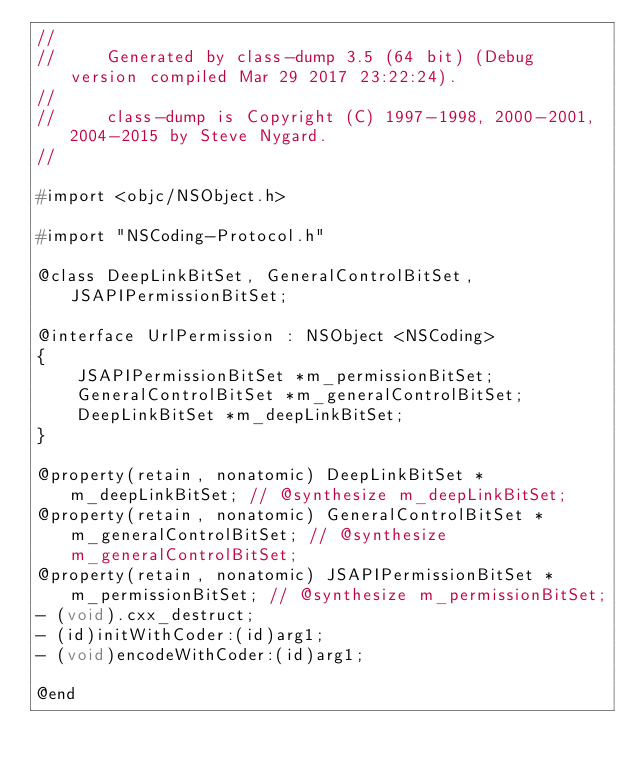Convert code to text. <code><loc_0><loc_0><loc_500><loc_500><_C_>//
//     Generated by class-dump 3.5 (64 bit) (Debug version compiled Mar 29 2017 23:22:24).
//
//     class-dump is Copyright (C) 1997-1998, 2000-2001, 2004-2015 by Steve Nygard.
//

#import <objc/NSObject.h>

#import "NSCoding-Protocol.h"

@class DeepLinkBitSet, GeneralControlBitSet, JSAPIPermissionBitSet;

@interface UrlPermission : NSObject <NSCoding>
{
    JSAPIPermissionBitSet *m_permissionBitSet;
    GeneralControlBitSet *m_generalControlBitSet;
    DeepLinkBitSet *m_deepLinkBitSet;
}

@property(retain, nonatomic) DeepLinkBitSet *m_deepLinkBitSet; // @synthesize m_deepLinkBitSet;
@property(retain, nonatomic) GeneralControlBitSet *m_generalControlBitSet; // @synthesize m_generalControlBitSet;
@property(retain, nonatomic) JSAPIPermissionBitSet *m_permissionBitSet; // @synthesize m_permissionBitSet;
- (void).cxx_destruct;
- (id)initWithCoder:(id)arg1;
- (void)encodeWithCoder:(id)arg1;

@end

</code> 